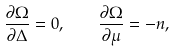<formula> <loc_0><loc_0><loc_500><loc_500>\frac { \partial \Omega } { \partial \Delta } = 0 , \quad \frac { \partial \Omega } { \partial \mu } = - n ,</formula> 